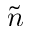Convert formula to latex. <formula><loc_0><loc_0><loc_500><loc_500>\tilde { n }</formula> 